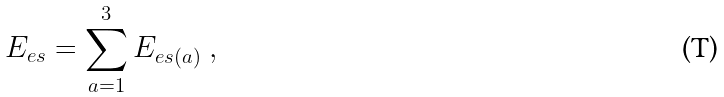Convert formula to latex. <formula><loc_0><loc_0><loc_500><loc_500>E _ { e s } = \sum _ { a = 1 } ^ { 3 } E _ { e s ( a ) } \ ,</formula> 